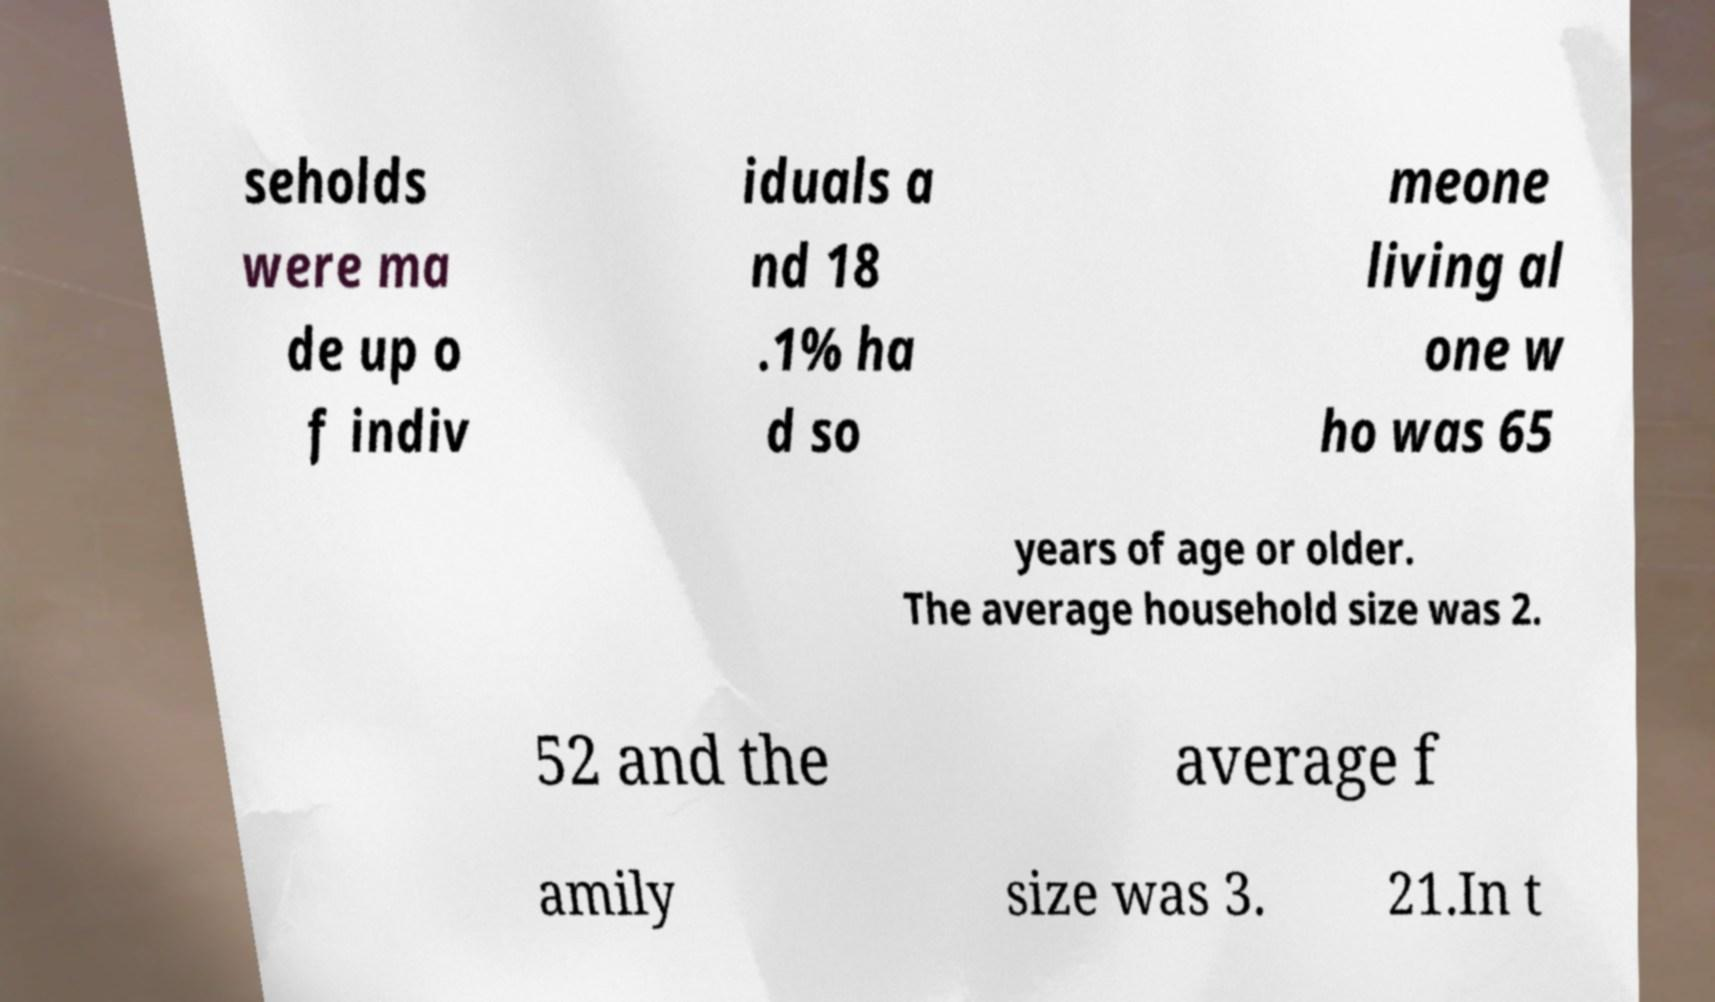Please identify and transcribe the text found in this image. seholds were ma de up o f indiv iduals a nd 18 .1% ha d so meone living al one w ho was 65 years of age or older. The average household size was 2. 52 and the average f amily size was 3. 21.In t 